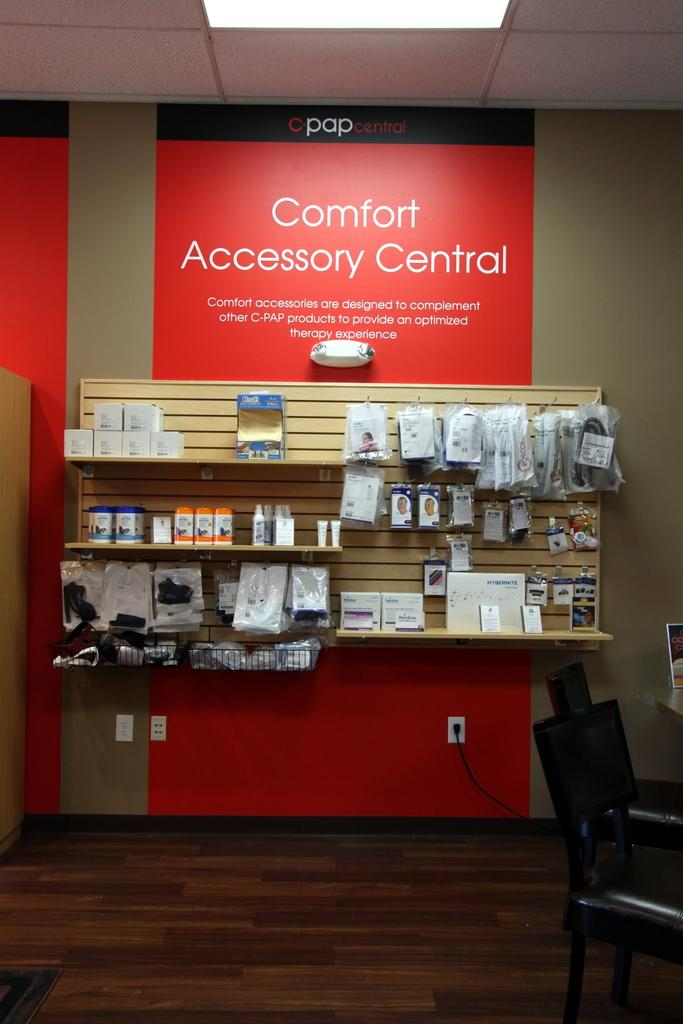<image>
Create a compact narrative representing the image presented. Area in a store with a red sign that says "Comfort Accessory Central". 